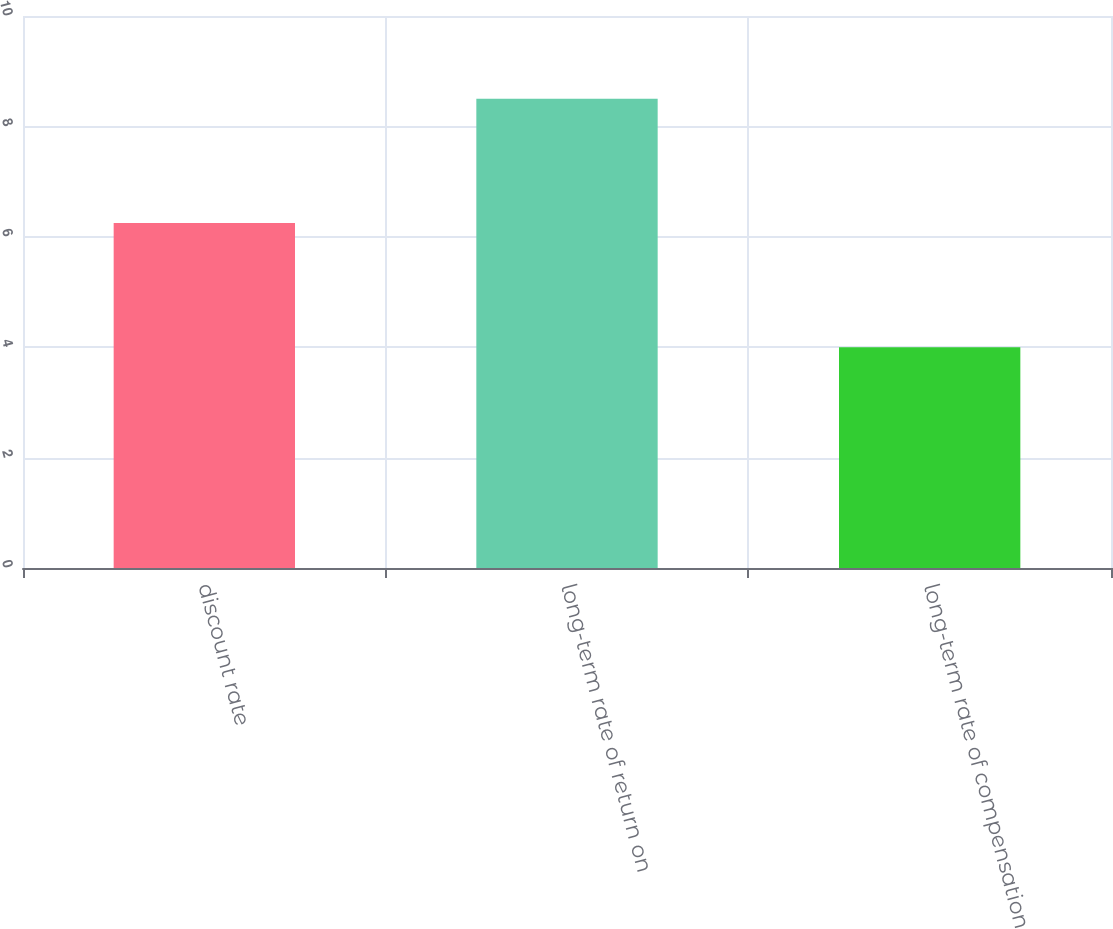Convert chart to OTSL. <chart><loc_0><loc_0><loc_500><loc_500><bar_chart><fcel>discount rate<fcel>long-term rate of return on<fcel>long-term rate of compensation<nl><fcel>6.25<fcel>8.5<fcel>4<nl></chart> 